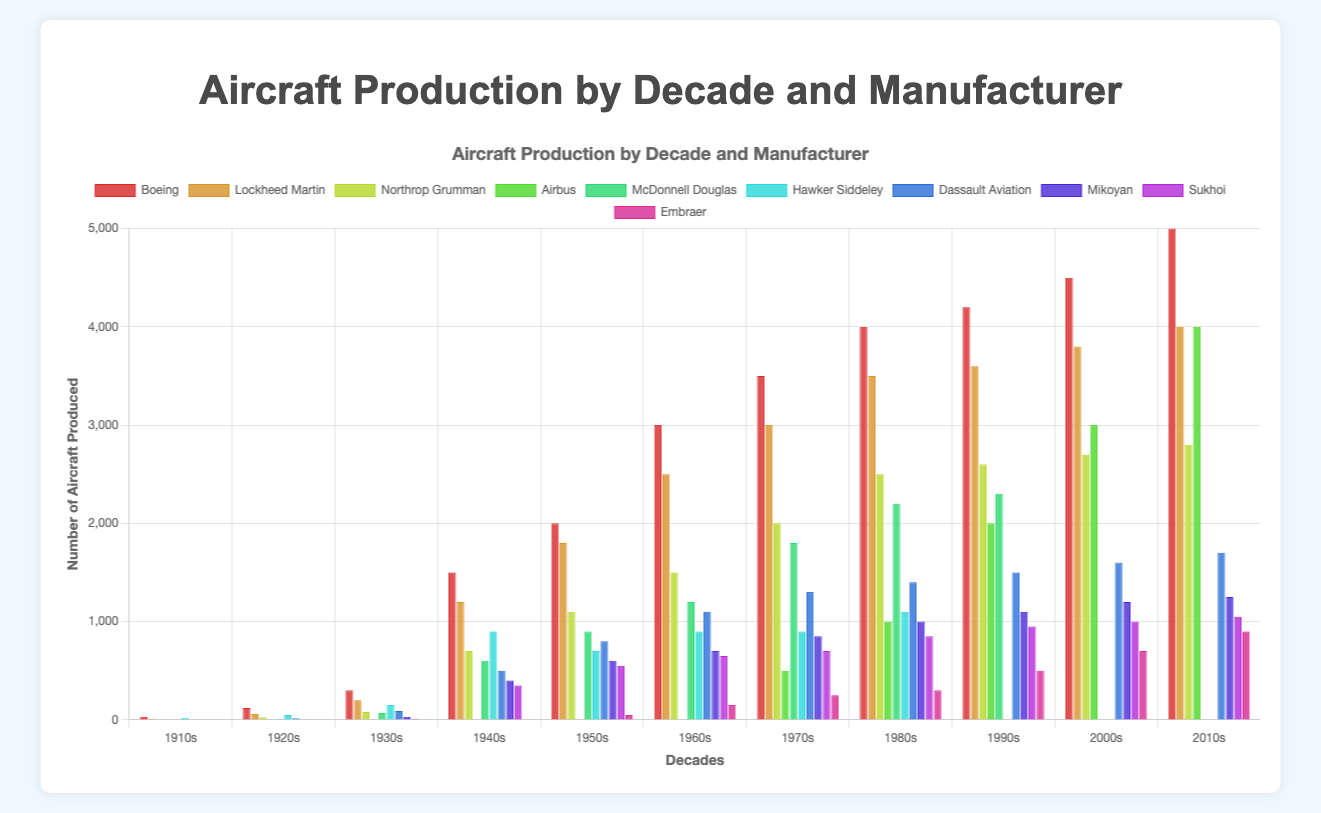How many aircraft did Embraer produce in the 2010s? Embraer produced 900 aircraft in the 2010s, which is shown in the bar corresponding to that decade in the figure.
Answer: 900 Which manufacturer produced the most aircraft in the 1940s, and how many did they produce? Boeing produced the most aircraft in the 1940s with 1500 units, as indicated by the tallest bar for that decade.
Answer: Boeing, 1500 Compare Boeing and Lockheed Martin's production in the 1950s. Which one produced more aircraft and by how much? Boeing produced 2000 aircraft, while Lockheed Martin produced 1800 aircraft in the 1950s. The difference is 200 aircraft.
Answer: Boeing, 200 In which decade did Airbus start producing aircraft according to the chart? Airbus started producing aircraft in the 1970s, as indicated by their first non-zero bar in that decade on the chart.
Answer: 1970s Across all decades, which manufacturer had the least aircraft production in the 1910s and how many were produced? Northrop Grumman produced the least aircraft in the 1910s with 5 units, shown by the shortest bar for that decade in the figure.
Answer: Northrop Grumman, 5 From the 1940s to the 2010s, which manufacturer had a consistently increasing production trend? Boeing had a consistently increasing production trend from the 1940s to the 2010s, as shown by the progressively taller bars for Boeing in each subsequent decade.
Answer: Boeing Calculate the total number of aircraft produced by Dassault Aviation from the 1910s to the 2010s. Sum up the number of aircraft Dassault Aviation produced in each decade: 0 + 15 + 90 + 500 + 800 + 1100 + 1300 + 1400 + 1500 + 1600 + 1700 = 10005.
Answer: 10005 Which manufacturer had their highest production in the 1980s, and what was the number produced? McDonnell Douglas had their highest production in the 1980s with 2200 units, as shown by the highest bar for that manufacturer in the figure.
Answer: McDonnell Douglas, 2200 Between Mikoyan and Sukhoi, which had higher total production in the 1950s, 1960s, and 1970s combined? Mikoyan: 600 + 700 + 850 = 2150, Sukhoi: 550 + 650 + 700 = 1900. Mikoyan had higher total production.
Answer: Mikoyan Which decade shows the largest difference in aircraft production between Boeing and Airbus? In the 1970s, the difference between Boeing and Airbus production was largest: 3500 (Boeing) - 500 (Airbus) = 3000.
Answer: 1970s 